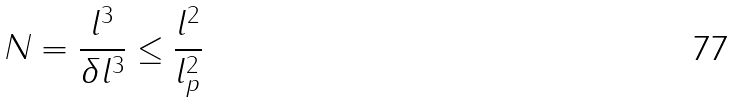<formula> <loc_0><loc_0><loc_500><loc_500>N = \frac { l ^ { 3 } } { \delta l ^ { 3 } } \leq \frac { l ^ { 2 } } { l _ { p } ^ { 2 } }</formula> 